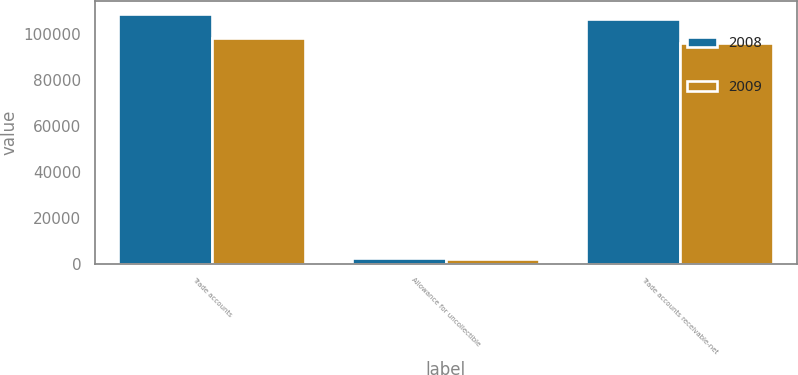Convert chart to OTSL. <chart><loc_0><loc_0><loc_500><loc_500><stacked_bar_chart><ecel><fcel>Trade accounts<fcel>Allowance for uncollectible<fcel>Trade accounts receivable-net<nl><fcel>2008<fcel>108894<fcel>2448<fcel>106446<nl><fcel>2009<fcel>98378<fcel>2182<fcel>96196<nl></chart> 